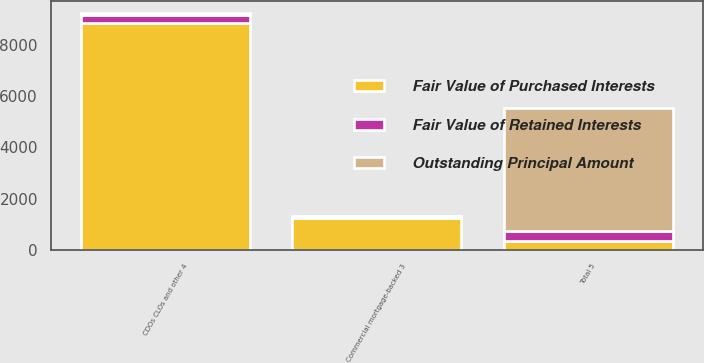Convert chart to OTSL. <chart><loc_0><loc_0><loc_500><loc_500><stacked_bar_chart><ecel><fcel>Commercial mortgage-backed 3<fcel>CDOs CLOs and other 4<fcel>Total 5<nl><fcel>Fair Value of Purchased Interests<fcel>1253<fcel>8866<fcel>359<nl><fcel>Outstanding Principal Amount<fcel>1<fcel>51<fcel>4812<nl><fcel>Fair Value of Retained Interests<fcel>56<fcel>331<fcel>387<nl></chart> 